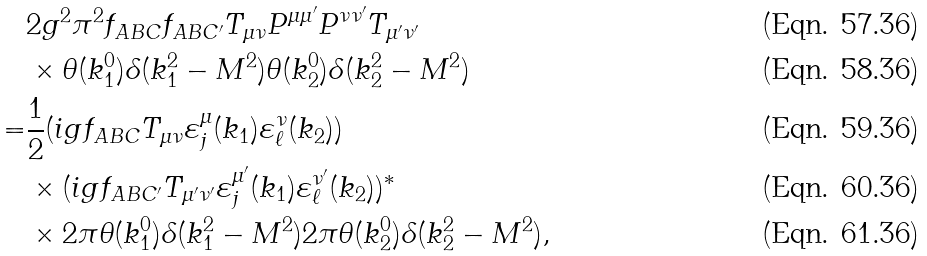Convert formula to latex. <formula><loc_0><loc_0><loc_500><loc_500>& 2 g ^ { 2 } \pi ^ { 2 } f _ { A B C } f _ { A B C ^ { \prime } } T _ { \mu \nu } P ^ { \mu \mu ^ { \prime } } P ^ { \nu \nu ^ { \prime } } T _ { \mu ^ { \prime } \nu ^ { \prime } } \\ & \times \theta ( k _ { 1 } ^ { 0 } ) \delta ( k _ { 1 } ^ { 2 } - M ^ { 2 } ) \theta ( k _ { 2 } ^ { 0 } ) \delta ( k _ { 2 } ^ { 2 } - M ^ { 2 } ) \\ = & \frac { 1 } { 2 } ( i g f _ { A B C } T _ { \mu \nu } \varepsilon ^ { \mu } _ { j } ( k _ { 1 } ) \varepsilon ^ { \nu } _ { \ell } ( k _ { 2 } ) ) \\ & \times ( i g f _ { A B C ^ { \prime } } T _ { \mu ^ { \prime } \nu ^ { \prime } } \varepsilon ^ { \mu ^ { \prime } } _ { j } ( k _ { 1 } ) \varepsilon ^ { \nu ^ { \prime } } _ { \ell } ( k _ { 2 } ) ) ^ { * } \\ & \times 2 \pi \theta ( k _ { 1 } ^ { 0 } ) \delta ( k _ { 1 } ^ { 2 } - M ^ { 2 } ) 2 \pi \theta ( k _ { 2 } ^ { 0 } ) \delta ( k _ { 2 } ^ { 2 } - M ^ { 2 } ) ,</formula> 